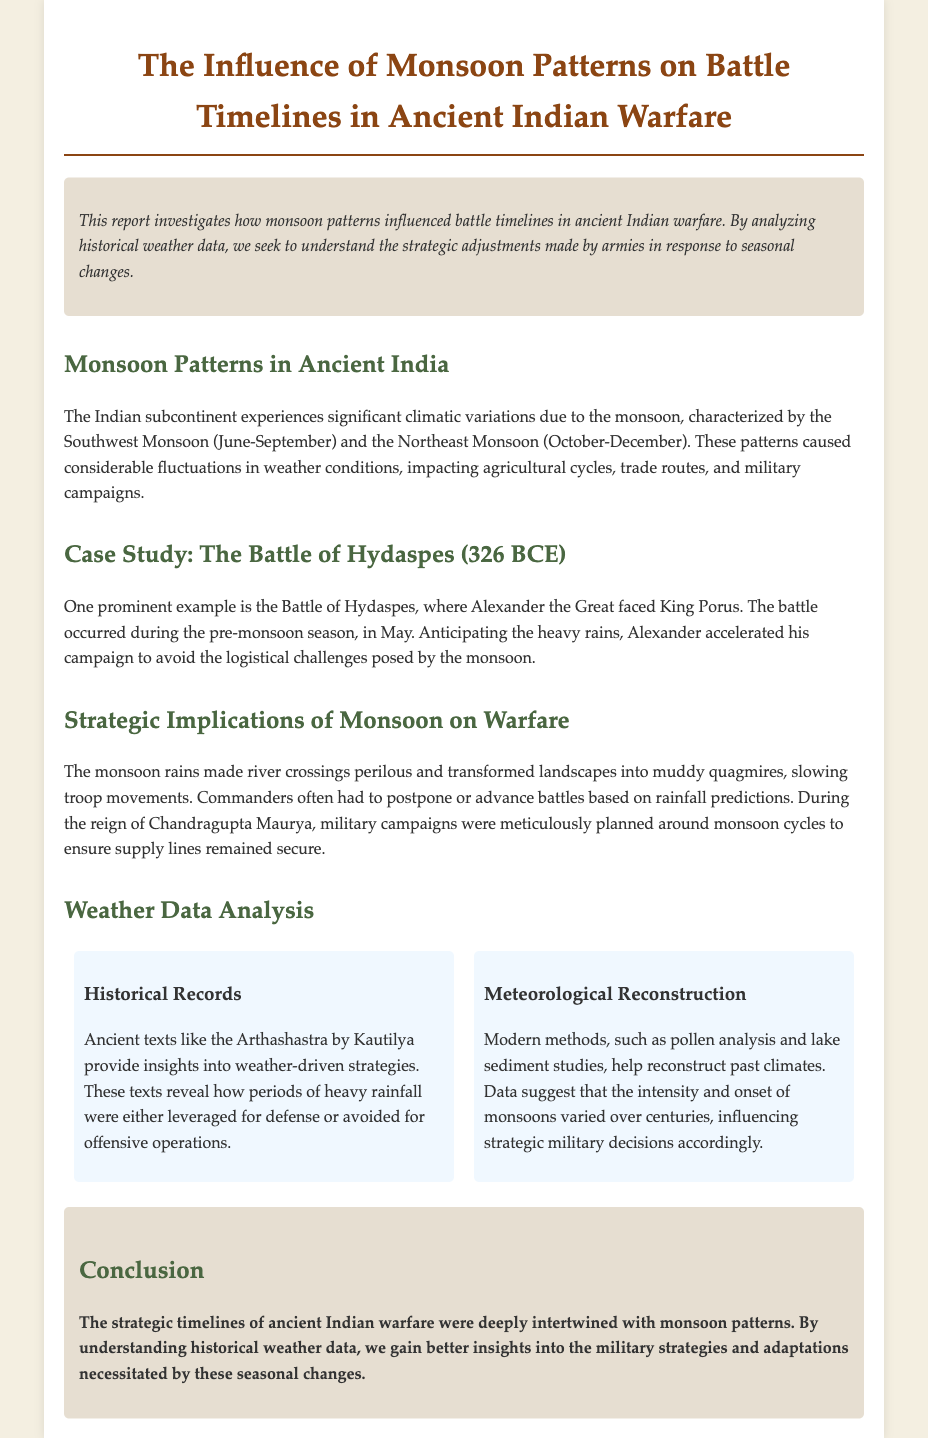What is the title of the report? The title of the report is provided at the beginning of the document, indicating the main focus of the analysis.
Answer: The Influence of Monsoon Patterns on Battle Timelines in Ancient Indian Warfare During which months does the Southwest Monsoon occur? The document describes the timing of significant monsoon seasons affecting the Indian subcontinent.
Answer: June-September What battle is highlighted in the case study? The document specifically mentions a historical battle as an example of the influence of monsoon patterns on warfare.
Answer: The Battle of Hydaspes Who faced King Porus in the highlighted battle? The document references a key figure in the battle discussed in the case study.
Answer: Alexander the Great What ancient text provides insights into weather-driven strategies? The document cites a significant historical text that informs military strategies regarding weather.
Answer: Arthashastra What strategic challenge is mentioned regarding rainfall? The document notes logistical difficulties faced by armies in ancient India due to specific weather conditions.
Answer: Troop movements How did Chandragupta Maurya plan military campaigns? The document discusses the planning strategies used by a prominent historical figure concerning seasonal weather.
Answer: Around monsoon cycles What method is used for meteorological reconstruction? The document lists a modern scientific approach for analyzing past climates to gather historical weather data.
Answer: Pollen analysis What type of conditions did monsoon rains create for military movements? The document describes the effects of seasonal rains on the battlefield, posing challenges for armies.
Answer: Muddy quagmires 